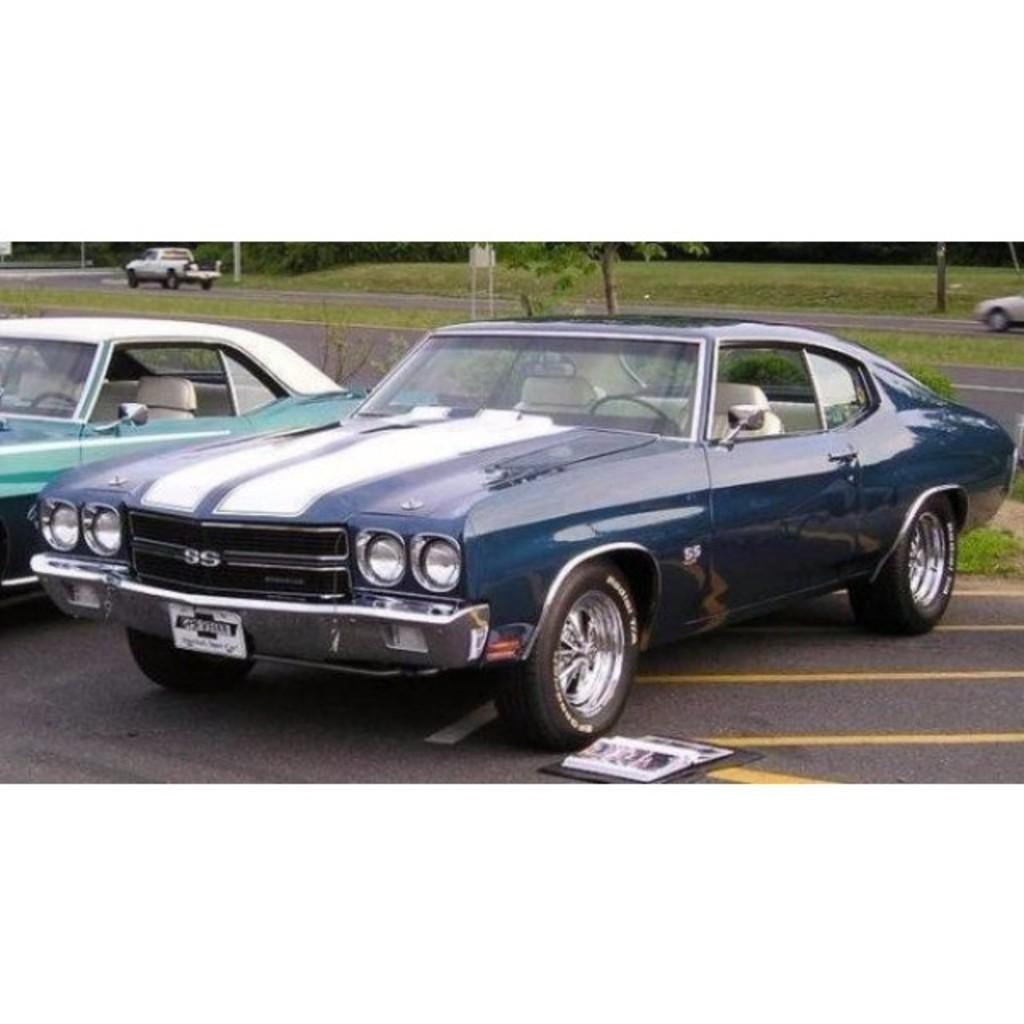How many parked vehicles can be seen in the image? There are two parked vehicles in the image. What is the status of the vehicles on the road? There are two moving vehicles on the road. What type of vegetation is present in the image? There are trees and grass in the image. What kind of object is on the road? There is an object on the road, but the specific type is not mentioned in the facts. What can be found near the road? There is a sign board in the image. How many flights are taking off from the nearby airport in the image? There is no information about flights or an airport in the image, so we cannot determine the number of flights taking off. What arithmetic problem can be solved using the number of trees in the image? There is no arithmetic problem mentioned or implied in the image, as it only provides information about the presence of trees. 